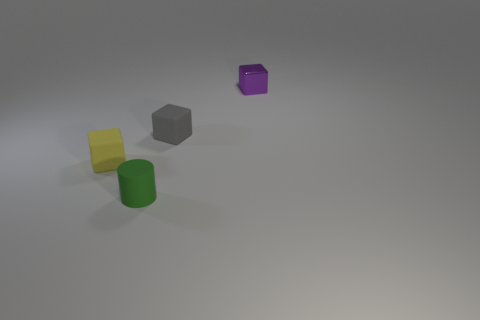Subtract all yellow cubes. How many cubes are left? 2 Subtract all gray blocks. How many blocks are left? 2 Subtract all cubes. How many objects are left? 1 Add 1 small red metal spheres. How many objects exist? 5 Subtract all yellow cubes. Subtract all cyan balls. How many cubes are left? 2 Subtract all green cubes. How many brown cylinders are left? 0 Subtract all tiny shiny blocks. Subtract all matte things. How many objects are left? 0 Add 2 small yellow blocks. How many small yellow blocks are left? 3 Add 3 small matte cubes. How many small matte cubes exist? 5 Subtract 0 red blocks. How many objects are left? 4 